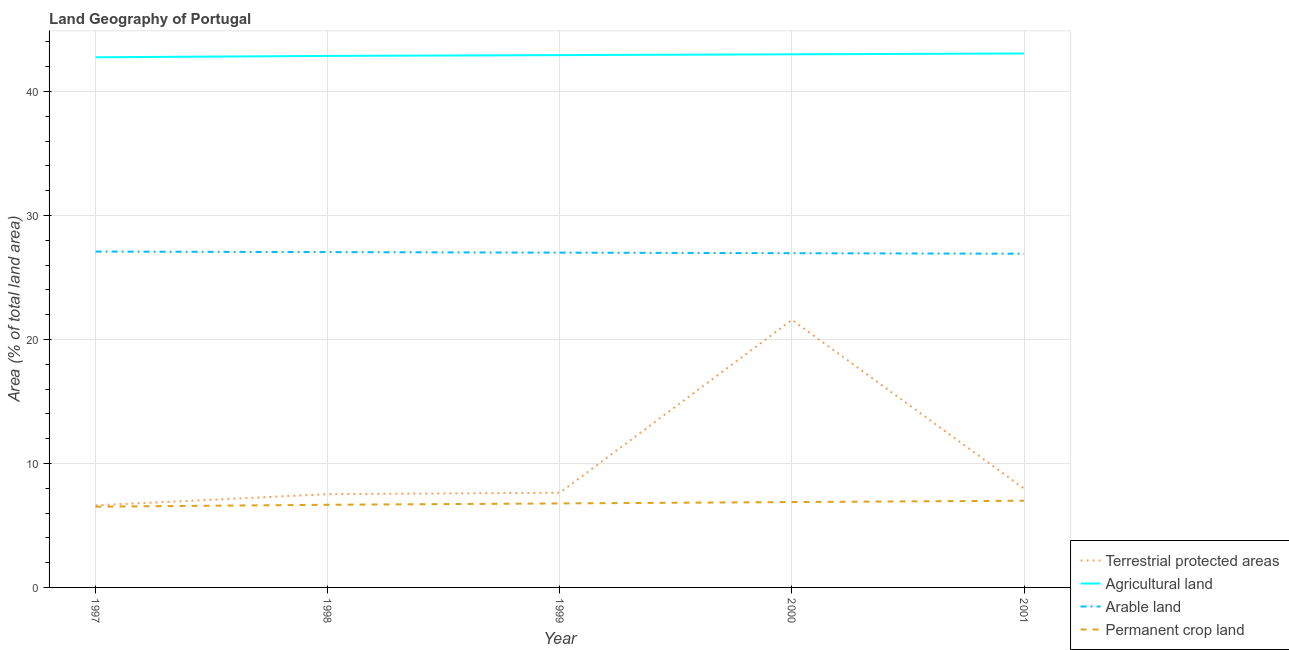Is the number of lines equal to the number of legend labels?
Provide a short and direct response. Yes. What is the percentage of area under agricultural land in 1998?
Ensure brevity in your answer.  42.87. Across all years, what is the maximum percentage of land under terrestrial protection?
Your response must be concise. 21.59. Across all years, what is the minimum percentage of area under agricultural land?
Ensure brevity in your answer.  42.77. In which year was the percentage of area under arable land maximum?
Your answer should be compact. 1997. What is the total percentage of area under permanent crop land in the graph?
Your answer should be very brief. 33.84. What is the difference between the percentage of area under agricultural land in 1998 and that in 2001?
Offer a very short reply. -0.2. What is the difference between the percentage of area under permanent crop land in 1999 and the percentage of area under arable land in 1998?
Offer a terse response. -20.27. What is the average percentage of area under arable land per year?
Give a very brief answer. 27.01. In the year 1997, what is the difference between the percentage of land under terrestrial protection and percentage of area under agricultural land?
Give a very brief answer. -36.15. What is the ratio of the percentage of area under permanent crop land in 2000 to that in 2001?
Offer a very short reply. 0.98. Is the percentage of land under terrestrial protection in 1999 less than that in 2000?
Ensure brevity in your answer.  Yes. Is the difference between the percentage of area under permanent crop land in 1998 and 1999 greater than the difference between the percentage of area under agricultural land in 1998 and 1999?
Offer a very short reply. No. What is the difference between the highest and the second highest percentage of area under agricultural land?
Keep it short and to the point. 0.07. What is the difference between the highest and the lowest percentage of area under agricultural land?
Make the answer very short. 0.31. Is it the case that in every year, the sum of the percentage of area under agricultural land and percentage of area under permanent crop land is greater than the sum of percentage of area under arable land and percentage of land under terrestrial protection?
Ensure brevity in your answer.  No. Is it the case that in every year, the sum of the percentage of land under terrestrial protection and percentage of area under agricultural land is greater than the percentage of area under arable land?
Your answer should be very brief. Yes. Does the percentage of area under arable land monotonically increase over the years?
Make the answer very short. No. Is the percentage of area under agricultural land strictly greater than the percentage of area under permanent crop land over the years?
Make the answer very short. Yes. Is the percentage of area under permanent crop land strictly less than the percentage of area under agricultural land over the years?
Provide a succinct answer. Yes. How many lines are there?
Your answer should be compact. 4. Are the values on the major ticks of Y-axis written in scientific E-notation?
Your answer should be compact. No. How many legend labels are there?
Provide a short and direct response. 4. What is the title of the graph?
Ensure brevity in your answer.  Land Geography of Portugal. Does "Goods and services" appear as one of the legend labels in the graph?
Make the answer very short. No. What is the label or title of the X-axis?
Your response must be concise. Year. What is the label or title of the Y-axis?
Provide a short and direct response. Area (% of total land area). What is the Area (% of total land area) in Terrestrial protected areas in 1997?
Give a very brief answer. 6.62. What is the Area (% of total land area) of Agricultural land in 1997?
Give a very brief answer. 42.77. What is the Area (% of total land area) of Arable land in 1997?
Your response must be concise. 27.09. What is the Area (% of total land area) in Permanent crop land in 1997?
Offer a terse response. 6.51. What is the Area (% of total land area) in Terrestrial protected areas in 1998?
Your answer should be very brief. 7.53. What is the Area (% of total land area) in Agricultural land in 1998?
Offer a terse response. 42.87. What is the Area (% of total land area) of Arable land in 1998?
Keep it short and to the point. 27.05. What is the Area (% of total land area) in Permanent crop land in 1998?
Your answer should be compact. 6.67. What is the Area (% of total land area) of Terrestrial protected areas in 1999?
Your answer should be compact. 7.64. What is the Area (% of total land area) in Agricultural land in 1999?
Your answer should be very brief. 42.94. What is the Area (% of total land area) in Arable land in 1999?
Your answer should be very brief. 27.01. What is the Area (% of total land area) of Permanent crop land in 1999?
Your answer should be very brief. 6.78. What is the Area (% of total land area) of Terrestrial protected areas in 2000?
Your answer should be very brief. 21.59. What is the Area (% of total land area) of Agricultural land in 2000?
Offer a very short reply. 43.01. What is the Area (% of total land area) of Arable land in 2000?
Give a very brief answer. 26.96. What is the Area (% of total land area) in Permanent crop land in 2000?
Your response must be concise. 6.89. What is the Area (% of total land area) of Terrestrial protected areas in 2001?
Ensure brevity in your answer.  7.96. What is the Area (% of total land area) in Agricultural land in 2001?
Ensure brevity in your answer.  43.07. What is the Area (% of total land area) in Arable land in 2001?
Offer a terse response. 26.92. What is the Area (% of total land area) in Permanent crop land in 2001?
Offer a terse response. 6.99. Across all years, what is the maximum Area (% of total land area) of Terrestrial protected areas?
Provide a succinct answer. 21.59. Across all years, what is the maximum Area (% of total land area) of Agricultural land?
Give a very brief answer. 43.07. Across all years, what is the maximum Area (% of total land area) in Arable land?
Ensure brevity in your answer.  27.09. Across all years, what is the maximum Area (% of total land area) of Permanent crop land?
Your answer should be very brief. 6.99. Across all years, what is the minimum Area (% of total land area) of Terrestrial protected areas?
Make the answer very short. 6.62. Across all years, what is the minimum Area (% of total land area) in Agricultural land?
Keep it short and to the point. 42.77. Across all years, what is the minimum Area (% of total land area) in Arable land?
Provide a short and direct response. 26.92. Across all years, what is the minimum Area (% of total land area) of Permanent crop land?
Your response must be concise. 6.51. What is the total Area (% of total land area) in Terrestrial protected areas in the graph?
Ensure brevity in your answer.  51.33. What is the total Area (% of total land area) in Agricultural land in the graph?
Your response must be concise. 214.66. What is the total Area (% of total land area) of Arable land in the graph?
Keep it short and to the point. 135.03. What is the total Area (% of total land area) in Permanent crop land in the graph?
Offer a very short reply. 33.84. What is the difference between the Area (% of total land area) in Terrestrial protected areas in 1997 and that in 1998?
Offer a terse response. -0.91. What is the difference between the Area (% of total land area) in Agricultural land in 1997 and that in 1998?
Provide a short and direct response. -0.11. What is the difference between the Area (% of total land area) in Arable land in 1997 and that in 1998?
Provide a succinct answer. 0.04. What is the difference between the Area (% of total land area) of Permanent crop land in 1997 and that in 1998?
Your answer should be very brief. -0.15. What is the difference between the Area (% of total land area) in Terrestrial protected areas in 1997 and that in 1999?
Provide a short and direct response. -1.02. What is the difference between the Area (% of total land area) of Agricultural land in 1997 and that in 1999?
Make the answer very short. -0.17. What is the difference between the Area (% of total land area) of Arable land in 1997 and that in 1999?
Provide a succinct answer. 0.09. What is the difference between the Area (% of total land area) of Permanent crop land in 1997 and that in 1999?
Give a very brief answer. -0.26. What is the difference between the Area (% of total land area) in Terrestrial protected areas in 1997 and that in 2000?
Provide a succinct answer. -14.97. What is the difference between the Area (% of total land area) in Agricultural land in 1997 and that in 2000?
Offer a terse response. -0.24. What is the difference between the Area (% of total land area) in Arable land in 1997 and that in 2000?
Ensure brevity in your answer.  0.13. What is the difference between the Area (% of total land area) in Permanent crop land in 1997 and that in 2000?
Give a very brief answer. -0.37. What is the difference between the Area (% of total land area) in Terrestrial protected areas in 1997 and that in 2001?
Your answer should be compact. -1.35. What is the difference between the Area (% of total land area) in Agricultural land in 1997 and that in 2001?
Your answer should be very brief. -0.31. What is the difference between the Area (% of total land area) of Arable land in 1997 and that in 2001?
Ensure brevity in your answer.  0.17. What is the difference between the Area (% of total land area) of Permanent crop land in 1997 and that in 2001?
Provide a succinct answer. -0.48. What is the difference between the Area (% of total land area) in Terrestrial protected areas in 1998 and that in 1999?
Your answer should be very brief. -0.11. What is the difference between the Area (% of total land area) of Agricultural land in 1998 and that in 1999?
Provide a short and direct response. -0.07. What is the difference between the Area (% of total land area) of Arable land in 1998 and that in 1999?
Ensure brevity in your answer.  0.04. What is the difference between the Area (% of total land area) of Permanent crop land in 1998 and that in 1999?
Your answer should be very brief. -0.11. What is the difference between the Area (% of total land area) of Terrestrial protected areas in 1998 and that in 2000?
Your response must be concise. -14.06. What is the difference between the Area (% of total land area) in Agricultural land in 1998 and that in 2000?
Make the answer very short. -0.13. What is the difference between the Area (% of total land area) of Arable land in 1998 and that in 2000?
Your answer should be very brief. 0.09. What is the difference between the Area (% of total land area) in Permanent crop land in 1998 and that in 2000?
Ensure brevity in your answer.  -0.22. What is the difference between the Area (% of total land area) in Terrestrial protected areas in 1998 and that in 2001?
Your answer should be compact. -0.44. What is the difference between the Area (% of total land area) of Agricultural land in 1998 and that in 2001?
Your response must be concise. -0.2. What is the difference between the Area (% of total land area) in Arable land in 1998 and that in 2001?
Your answer should be compact. 0.13. What is the difference between the Area (% of total land area) of Permanent crop land in 1998 and that in 2001?
Keep it short and to the point. -0.33. What is the difference between the Area (% of total land area) of Terrestrial protected areas in 1999 and that in 2000?
Give a very brief answer. -13.95. What is the difference between the Area (% of total land area) of Agricultural land in 1999 and that in 2000?
Make the answer very short. -0.07. What is the difference between the Area (% of total land area) of Arable land in 1999 and that in 2000?
Offer a very short reply. 0.04. What is the difference between the Area (% of total land area) of Permanent crop land in 1999 and that in 2000?
Make the answer very short. -0.11. What is the difference between the Area (% of total land area) of Terrestrial protected areas in 1999 and that in 2001?
Give a very brief answer. -0.33. What is the difference between the Area (% of total land area) in Agricultural land in 1999 and that in 2001?
Offer a terse response. -0.13. What is the difference between the Area (% of total land area) in Arable land in 1999 and that in 2001?
Provide a short and direct response. 0.09. What is the difference between the Area (% of total land area) in Permanent crop land in 1999 and that in 2001?
Offer a terse response. -0.22. What is the difference between the Area (% of total land area) in Terrestrial protected areas in 2000 and that in 2001?
Make the answer very short. 13.62. What is the difference between the Area (% of total land area) in Agricultural land in 2000 and that in 2001?
Keep it short and to the point. -0.07. What is the difference between the Area (% of total land area) in Arable land in 2000 and that in 2001?
Your answer should be very brief. 0.04. What is the difference between the Area (% of total land area) in Permanent crop land in 2000 and that in 2001?
Your answer should be compact. -0.11. What is the difference between the Area (% of total land area) of Terrestrial protected areas in 1997 and the Area (% of total land area) of Agricultural land in 1998?
Your answer should be compact. -36.26. What is the difference between the Area (% of total land area) of Terrestrial protected areas in 1997 and the Area (% of total land area) of Arable land in 1998?
Give a very brief answer. -20.43. What is the difference between the Area (% of total land area) of Terrestrial protected areas in 1997 and the Area (% of total land area) of Permanent crop land in 1998?
Offer a very short reply. -0.05. What is the difference between the Area (% of total land area) in Agricultural land in 1997 and the Area (% of total land area) in Arable land in 1998?
Ensure brevity in your answer.  15.72. What is the difference between the Area (% of total land area) of Agricultural land in 1997 and the Area (% of total land area) of Permanent crop land in 1998?
Your response must be concise. 36.1. What is the difference between the Area (% of total land area) of Arable land in 1997 and the Area (% of total land area) of Permanent crop land in 1998?
Keep it short and to the point. 20.43. What is the difference between the Area (% of total land area) in Terrestrial protected areas in 1997 and the Area (% of total land area) in Agricultural land in 1999?
Your answer should be very brief. -36.32. What is the difference between the Area (% of total land area) of Terrestrial protected areas in 1997 and the Area (% of total land area) of Arable land in 1999?
Your response must be concise. -20.39. What is the difference between the Area (% of total land area) of Terrestrial protected areas in 1997 and the Area (% of total land area) of Permanent crop land in 1999?
Make the answer very short. -0.16. What is the difference between the Area (% of total land area) in Agricultural land in 1997 and the Area (% of total land area) in Arable land in 1999?
Your answer should be compact. 15.76. What is the difference between the Area (% of total land area) of Agricultural land in 1997 and the Area (% of total land area) of Permanent crop land in 1999?
Ensure brevity in your answer.  35.99. What is the difference between the Area (% of total land area) in Arable land in 1997 and the Area (% of total land area) in Permanent crop land in 1999?
Provide a succinct answer. 20.32. What is the difference between the Area (% of total land area) in Terrestrial protected areas in 1997 and the Area (% of total land area) in Agricultural land in 2000?
Give a very brief answer. -36.39. What is the difference between the Area (% of total land area) of Terrestrial protected areas in 1997 and the Area (% of total land area) of Arable land in 2000?
Your answer should be compact. -20.34. What is the difference between the Area (% of total land area) in Terrestrial protected areas in 1997 and the Area (% of total land area) in Permanent crop land in 2000?
Provide a short and direct response. -0.27. What is the difference between the Area (% of total land area) of Agricultural land in 1997 and the Area (% of total land area) of Arable land in 2000?
Your response must be concise. 15.8. What is the difference between the Area (% of total land area) in Agricultural land in 1997 and the Area (% of total land area) in Permanent crop land in 2000?
Provide a short and direct response. 35.88. What is the difference between the Area (% of total land area) in Arable land in 1997 and the Area (% of total land area) in Permanent crop land in 2000?
Keep it short and to the point. 20.21. What is the difference between the Area (% of total land area) in Terrestrial protected areas in 1997 and the Area (% of total land area) in Agricultural land in 2001?
Your answer should be compact. -36.45. What is the difference between the Area (% of total land area) in Terrestrial protected areas in 1997 and the Area (% of total land area) in Arable land in 2001?
Offer a terse response. -20.3. What is the difference between the Area (% of total land area) in Terrestrial protected areas in 1997 and the Area (% of total land area) in Permanent crop land in 2001?
Your answer should be very brief. -0.38. What is the difference between the Area (% of total land area) in Agricultural land in 1997 and the Area (% of total land area) in Arable land in 2001?
Offer a terse response. 15.85. What is the difference between the Area (% of total land area) in Agricultural land in 1997 and the Area (% of total land area) in Permanent crop land in 2001?
Provide a succinct answer. 35.77. What is the difference between the Area (% of total land area) of Arable land in 1997 and the Area (% of total land area) of Permanent crop land in 2001?
Offer a very short reply. 20.1. What is the difference between the Area (% of total land area) in Terrestrial protected areas in 1998 and the Area (% of total land area) in Agricultural land in 1999?
Offer a very short reply. -35.41. What is the difference between the Area (% of total land area) of Terrestrial protected areas in 1998 and the Area (% of total land area) of Arable land in 1999?
Your answer should be very brief. -19.48. What is the difference between the Area (% of total land area) in Terrestrial protected areas in 1998 and the Area (% of total land area) in Permanent crop land in 1999?
Keep it short and to the point. 0.75. What is the difference between the Area (% of total land area) of Agricultural land in 1998 and the Area (% of total land area) of Arable land in 1999?
Give a very brief answer. 15.87. What is the difference between the Area (% of total land area) of Agricultural land in 1998 and the Area (% of total land area) of Permanent crop land in 1999?
Provide a succinct answer. 36.1. What is the difference between the Area (% of total land area) in Arable land in 1998 and the Area (% of total land area) in Permanent crop land in 1999?
Your response must be concise. 20.27. What is the difference between the Area (% of total land area) of Terrestrial protected areas in 1998 and the Area (% of total land area) of Agricultural land in 2000?
Keep it short and to the point. -35.48. What is the difference between the Area (% of total land area) in Terrestrial protected areas in 1998 and the Area (% of total land area) in Arable land in 2000?
Offer a terse response. -19.44. What is the difference between the Area (% of total land area) in Terrestrial protected areas in 1998 and the Area (% of total land area) in Permanent crop land in 2000?
Your response must be concise. 0.64. What is the difference between the Area (% of total land area) of Agricultural land in 1998 and the Area (% of total land area) of Arable land in 2000?
Offer a terse response. 15.91. What is the difference between the Area (% of total land area) of Agricultural land in 1998 and the Area (% of total land area) of Permanent crop land in 2000?
Ensure brevity in your answer.  35.99. What is the difference between the Area (% of total land area) in Arable land in 1998 and the Area (% of total land area) in Permanent crop land in 2000?
Your answer should be very brief. 20.16. What is the difference between the Area (% of total land area) in Terrestrial protected areas in 1998 and the Area (% of total land area) in Agricultural land in 2001?
Provide a succinct answer. -35.55. What is the difference between the Area (% of total land area) in Terrestrial protected areas in 1998 and the Area (% of total land area) in Arable land in 2001?
Offer a very short reply. -19.39. What is the difference between the Area (% of total land area) in Terrestrial protected areas in 1998 and the Area (% of total land area) in Permanent crop land in 2001?
Make the answer very short. 0.53. What is the difference between the Area (% of total land area) of Agricultural land in 1998 and the Area (% of total land area) of Arable land in 2001?
Your response must be concise. 15.96. What is the difference between the Area (% of total land area) in Agricultural land in 1998 and the Area (% of total land area) in Permanent crop land in 2001?
Your answer should be compact. 35.88. What is the difference between the Area (% of total land area) of Arable land in 1998 and the Area (% of total land area) of Permanent crop land in 2001?
Keep it short and to the point. 20.05. What is the difference between the Area (% of total land area) of Terrestrial protected areas in 1999 and the Area (% of total land area) of Agricultural land in 2000?
Provide a short and direct response. -35.37. What is the difference between the Area (% of total land area) of Terrestrial protected areas in 1999 and the Area (% of total land area) of Arable land in 2000?
Your response must be concise. -19.32. What is the difference between the Area (% of total land area) in Terrestrial protected areas in 1999 and the Area (% of total land area) in Permanent crop land in 2000?
Your response must be concise. 0.75. What is the difference between the Area (% of total land area) of Agricultural land in 1999 and the Area (% of total land area) of Arable land in 2000?
Your answer should be compact. 15.98. What is the difference between the Area (% of total land area) in Agricultural land in 1999 and the Area (% of total land area) in Permanent crop land in 2000?
Offer a terse response. 36.05. What is the difference between the Area (% of total land area) of Arable land in 1999 and the Area (% of total land area) of Permanent crop land in 2000?
Make the answer very short. 20.12. What is the difference between the Area (% of total land area) of Terrestrial protected areas in 1999 and the Area (% of total land area) of Agricultural land in 2001?
Offer a very short reply. -35.43. What is the difference between the Area (% of total land area) in Terrestrial protected areas in 1999 and the Area (% of total land area) in Arable land in 2001?
Offer a very short reply. -19.28. What is the difference between the Area (% of total land area) in Terrestrial protected areas in 1999 and the Area (% of total land area) in Permanent crop land in 2001?
Your answer should be very brief. 0.64. What is the difference between the Area (% of total land area) in Agricultural land in 1999 and the Area (% of total land area) in Arable land in 2001?
Your response must be concise. 16.02. What is the difference between the Area (% of total land area) in Agricultural land in 1999 and the Area (% of total land area) in Permanent crop land in 2001?
Make the answer very short. 35.95. What is the difference between the Area (% of total land area) of Arable land in 1999 and the Area (% of total land area) of Permanent crop land in 2001?
Give a very brief answer. 20.01. What is the difference between the Area (% of total land area) in Terrestrial protected areas in 2000 and the Area (% of total land area) in Agricultural land in 2001?
Make the answer very short. -21.49. What is the difference between the Area (% of total land area) in Terrestrial protected areas in 2000 and the Area (% of total land area) in Arable land in 2001?
Provide a succinct answer. -5.33. What is the difference between the Area (% of total land area) of Terrestrial protected areas in 2000 and the Area (% of total land area) of Permanent crop land in 2001?
Your answer should be very brief. 14.59. What is the difference between the Area (% of total land area) of Agricultural land in 2000 and the Area (% of total land area) of Arable land in 2001?
Make the answer very short. 16.09. What is the difference between the Area (% of total land area) in Agricultural land in 2000 and the Area (% of total land area) in Permanent crop land in 2001?
Keep it short and to the point. 36.01. What is the difference between the Area (% of total land area) in Arable land in 2000 and the Area (% of total land area) in Permanent crop land in 2001?
Your response must be concise. 19.97. What is the average Area (% of total land area) of Terrestrial protected areas per year?
Provide a short and direct response. 10.27. What is the average Area (% of total land area) in Agricultural land per year?
Give a very brief answer. 42.93. What is the average Area (% of total land area) in Arable land per year?
Keep it short and to the point. 27.01. What is the average Area (% of total land area) in Permanent crop land per year?
Offer a terse response. 6.77. In the year 1997, what is the difference between the Area (% of total land area) of Terrestrial protected areas and Area (% of total land area) of Agricultural land?
Keep it short and to the point. -36.15. In the year 1997, what is the difference between the Area (% of total land area) of Terrestrial protected areas and Area (% of total land area) of Arable land?
Your answer should be very brief. -20.47. In the year 1997, what is the difference between the Area (% of total land area) of Terrestrial protected areas and Area (% of total land area) of Permanent crop land?
Your response must be concise. 0.11. In the year 1997, what is the difference between the Area (% of total land area) in Agricultural land and Area (% of total land area) in Arable land?
Offer a terse response. 15.67. In the year 1997, what is the difference between the Area (% of total land area) of Agricultural land and Area (% of total land area) of Permanent crop land?
Your answer should be very brief. 36.25. In the year 1997, what is the difference between the Area (% of total land area) of Arable land and Area (% of total land area) of Permanent crop land?
Provide a succinct answer. 20.58. In the year 1998, what is the difference between the Area (% of total land area) of Terrestrial protected areas and Area (% of total land area) of Agricultural land?
Your answer should be very brief. -35.35. In the year 1998, what is the difference between the Area (% of total land area) of Terrestrial protected areas and Area (% of total land area) of Arable land?
Provide a short and direct response. -19.52. In the year 1998, what is the difference between the Area (% of total land area) in Terrestrial protected areas and Area (% of total land area) in Permanent crop land?
Offer a terse response. 0.86. In the year 1998, what is the difference between the Area (% of total land area) in Agricultural land and Area (% of total land area) in Arable land?
Offer a very short reply. 15.83. In the year 1998, what is the difference between the Area (% of total land area) in Agricultural land and Area (% of total land area) in Permanent crop land?
Offer a terse response. 36.21. In the year 1998, what is the difference between the Area (% of total land area) of Arable land and Area (% of total land area) of Permanent crop land?
Keep it short and to the point. 20.38. In the year 1999, what is the difference between the Area (% of total land area) of Terrestrial protected areas and Area (% of total land area) of Agricultural land?
Provide a short and direct response. -35.3. In the year 1999, what is the difference between the Area (% of total land area) in Terrestrial protected areas and Area (% of total land area) in Arable land?
Provide a short and direct response. -19.37. In the year 1999, what is the difference between the Area (% of total land area) of Terrestrial protected areas and Area (% of total land area) of Permanent crop land?
Give a very brief answer. 0.86. In the year 1999, what is the difference between the Area (% of total land area) of Agricultural land and Area (% of total land area) of Arable land?
Make the answer very short. 15.93. In the year 1999, what is the difference between the Area (% of total land area) of Agricultural land and Area (% of total land area) of Permanent crop land?
Your answer should be very brief. 36.16. In the year 1999, what is the difference between the Area (% of total land area) of Arable land and Area (% of total land area) of Permanent crop land?
Offer a terse response. 20.23. In the year 2000, what is the difference between the Area (% of total land area) of Terrestrial protected areas and Area (% of total land area) of Agricultural land?
Keep it short and to the point. -21.42. In the year 2000, what is the difference between the Area (% of total land area) in Terrestrial protected areas and Area (% of total land area) in Arable land?
Offer a terse response. -5.38. In the year 2000, what is the difference between the Area (% of total land area) of Terrestrial protected areas and Area (% of total land area) of Permanent crop land?
Your answer should be very brief. 14.7. In the year 2000, what is the difference between the Area (% of total land area) of Agricultural land and Area (% of total land area) of Arable land?
Give a very brief answer. 16.04. In the year 2000, what is the difference between the Area (% of total land area) of Agricultural land and Area (% of total land area) of Permanent crop land?
Ensure brevity in your answer.  36.12. In the year 2000, what is the difference between the Area (% of total land area) of Arable land and Area (% of total land area) of Permanent crop land?
Offer a terse response. 20.08. In the year 2001, what is the difference between the Area (% of total land area) of Terrestrial protected areas and Area (% of total land area) of Agricultural land?
Offer a very short reply. -35.11. In the year 2001, what is the difference between the Area (% of total land area) in Terrestrial protected areas and Area (% of total land area) in Arable land?
Make the answer very short. -18.95. In the year 2001, what is the difference between the Area (% of total land area) of Terrestrial protected areas and Area (% of total land area) of Permanent crop land?
Your response must be concise. 0.97. In the year 2001, what is the difference between the Area (% of total land area) of Agricultural land and Area (% of total land area) of Arable land?
Give a very brief answer. 16.15. In the year 2001, what is the difference between the Area (% of total land area) of Agricultural land and Area (% of total land area) of Permanent crop land?
Make the answer very short. 36.08. In the year 2001, what is the difference between the Area (% of total land area) in Arable land and Area (% of total land area) in Permanent crop land?
Make the answer very short. 19.92. What is the ratio of the Area (% of total land area) in Terrestrial protected areas in 1997 to that in 1998?
Keep it short and to the point. 0.88. What is the ratio of the Area (% of total land area) of Agricultural land in 1997 to that in 1998?
Offer a terse response. 1. What is the ratio of the Area (% of total land area) of Permanent crop land in 1997 to that in 1998?
Provide a short and direct response. 0.98. What is the ratio of the Area (% of total land area) in Terrestrial protected areas in 1997 to that in 1999?
Your answer should be very brief. 0.87. What is the ratio of the Area (% of total land area) in Agricultural land in 1997 to that in 1999?
Make the answer very short. 1. What is the ratio of the Area (% of total land area) in Arable land in 1997 to that in 1999?
Keep it short and to the point. 1. What is the ratio of the Area (% of total land area) in Permanent crop land in 1997 to that in 1999?
Provide a succinct answer. 0.96. What is the ratio of the Area (% of total land area) in Terrestrial protected areas in 1997 to that in 2000?
Make the answer very short. 0.31. What is the ratio of the Area (% of total land area) of Agricultural land in 1997 to that in 2000?
Provide a succinct answer. 0.99. What is the ratio of the Area (% of total land area) in Permanent crop land in 1997 to that in 2000?
Your response must be concise. 0.95. What is the ratio of the Area (% of total land area) of Terrestrial protected areas in 1997 to that in 2001?
Your answer should be compact. 0.83. What is the ratio of the Area (% of total land area) of Agricultural land in 1997 to that in 2001?
Offer a terse response. 0.99. What is the ratio of the Area (% of total land area) of Permanent crop land in 1997 to that in 2001?
Keep it short and to the point. 0.93. What is the ratio of the Area (% of total land area) of Agricultural land in 1998 to that in 1999?
Offer a terse response. 1. What is the ratio of the Area (% of total land area) of Permanent crop land in 1998 to that in 1999?
Your answer should be very brief. 0.98. What is the ratio of the Area (% of total land area) of Terrestrial protected areas in 1998 to that in 2000?
Give a very brief answer. 0.35. What is the ratio of the Area (% of total land area) in Permanent crop land in 1998 to that in 2000?
Offer a very short reply. 0.97. What is the ratio of the Area (% of total land area) in Terrestrial protected areas in 1998 to that in 2001?
Offer a very short reply. 0.94. What is the ratio of the Area (% of total land area) in Arable land in 1998 to that in 2001?
Provide a short and direct response. 1. What is the ratio of the Area (% of total land area) in Permanent crop land in 1998 to that in 2001?
Offer a terse response. 0.95. What is the ratio of the Area (% of total land area) in Terrestrial protected areas in 1999 to that in 2000?
Your answer should be compact. 0.35. What is the ratio of the Area (% of total land area) of Agricultural land in 1999 to that in 2000?
Your response must be concise. 1. What is the ratio of the Area (% of total land area) in Permanent crop land in 1999 to that in 2000?
Make the answer very short. 0.98. What is the ratio of the Area (% of total land area) in Permanent crop land in 1999 to that in 2001?
Offer a terse response. 0.97. What is the ratio of the Area (% of total land area) in Terrestrial protected areas in 2000 to that in 2001?
Make the answer very short. 2.71. What is the ratio of the Area (% of total land area) of Permanent crop land in 2000 to that in 2001?
Keep it short and to the point. 0.98. What is the difference between the highest and the second highest Area (% of total land area) in Terrestrial protected areas?
Provide a short and direct response. 13.62. What is the difference between the highest and the second highest Area (% of total land area) in Agricultural land?
Your answer should be very brief. 0.07. What is the difference between the highest and the second highest Area (% of total land area) of Arable land?
Make the answer very short. 0.04. What is the difference between the highest and the second highest Area (% of total land area) in Permanent crop land?
Ensure brevity in your answer.  0.11. What is the difference between the highest and the lowest Area (% of total land area) in Terrestrial protected areas?
Ensure brevity in your answer.  14.97. What is the difference between the highest and the lowest Area (% of total land area) of Agricultural land?
Provide a short and direct response. 0.31. What is the difference between the highest and the lowest Area (% of total land area) in Arable land?
Give a very brief answer. 0.17. What is the difference between the highest and the lowest Area (% of total land area) of Permanent crop land?
Provide a short and direct response. 0.48. 